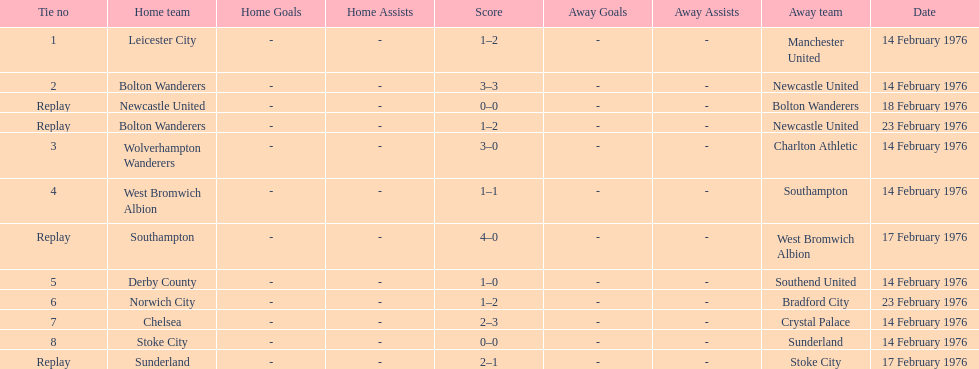What was the number of games that occurred on 14 february 1976? 7. 